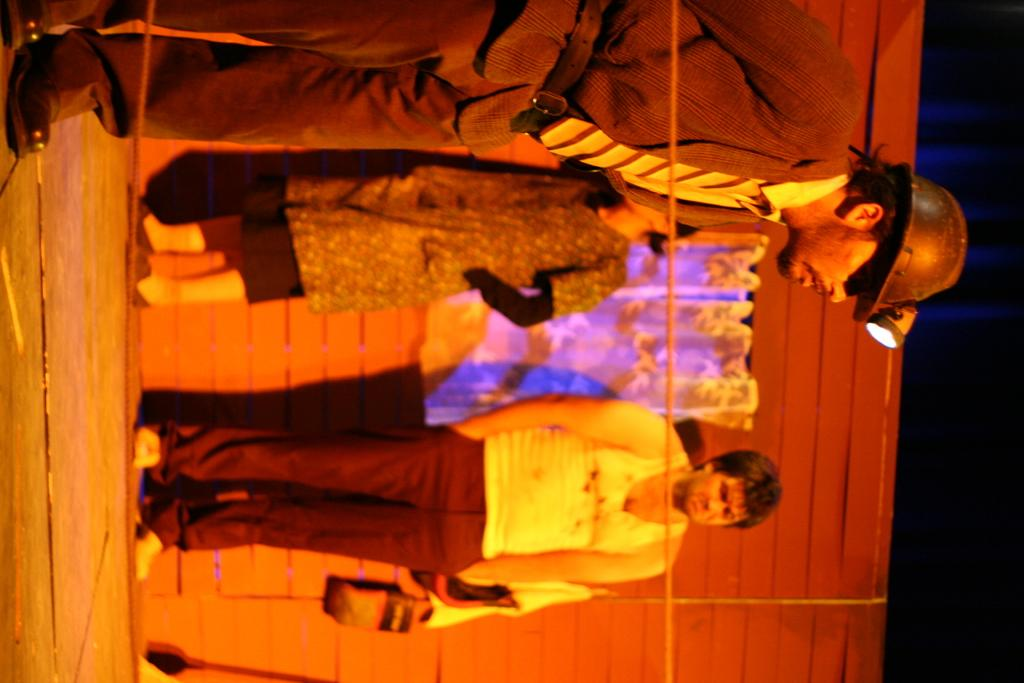How many people are in the image? A: There are three people standing in the image. What are the people doing in the image? The people are looking at the ground. What can be seen in the background of the image? There is a wall in the background of the image. What is hanging on the wall in the image? A curtain is hanging on the wall. What type of alarm is beeping in the image? There is no alarm present in the image. What is the texture of the wool in the image? There is no wool present in the image. 